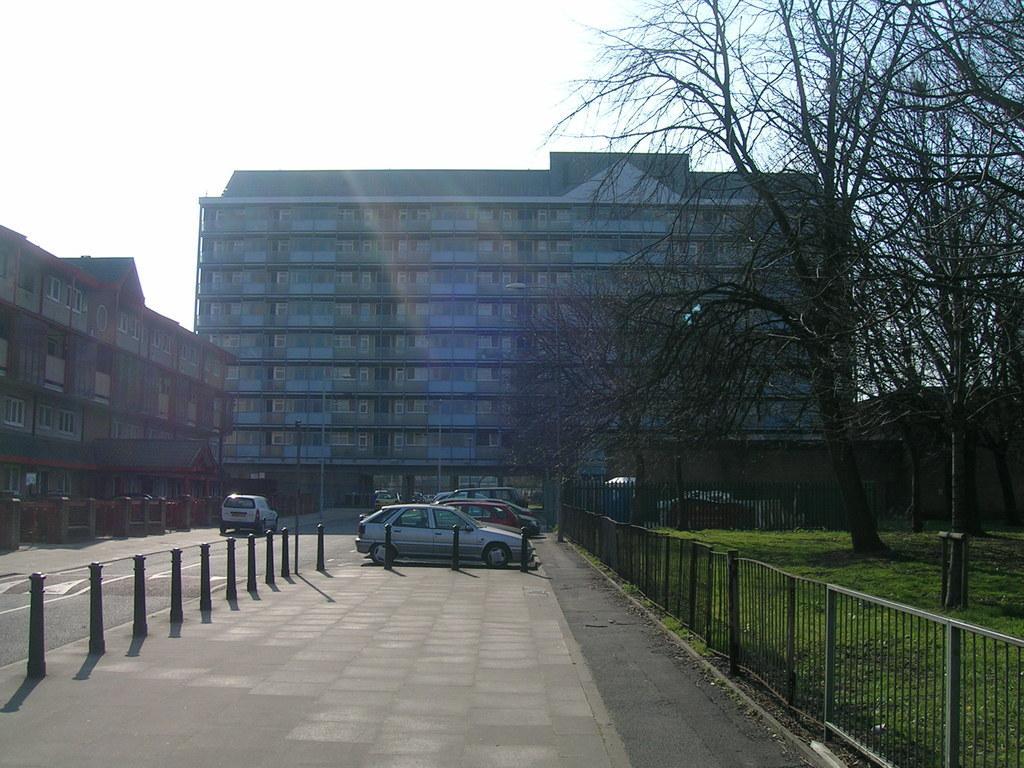Describe this image in one or two sentences. In this image we can see vehicles and poles. Also there is a road. On the right side there are railings and trees. On the ground there is grass. There are buildings with windows. In the background there is sky. 